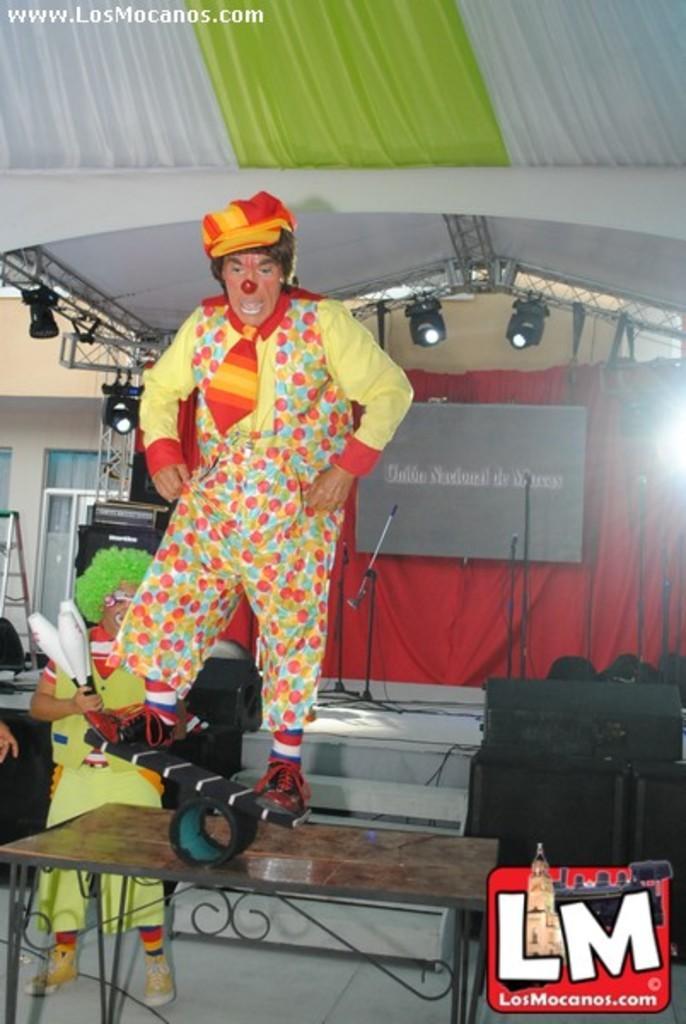Could you give a brief overview of what you see in this image? In this image we can see clowns. At the bottom there is a table and we can see speakers. In the background there are stands, board and a curtain. At the top there are lights and we can see a building. On the left there is a ladder. 